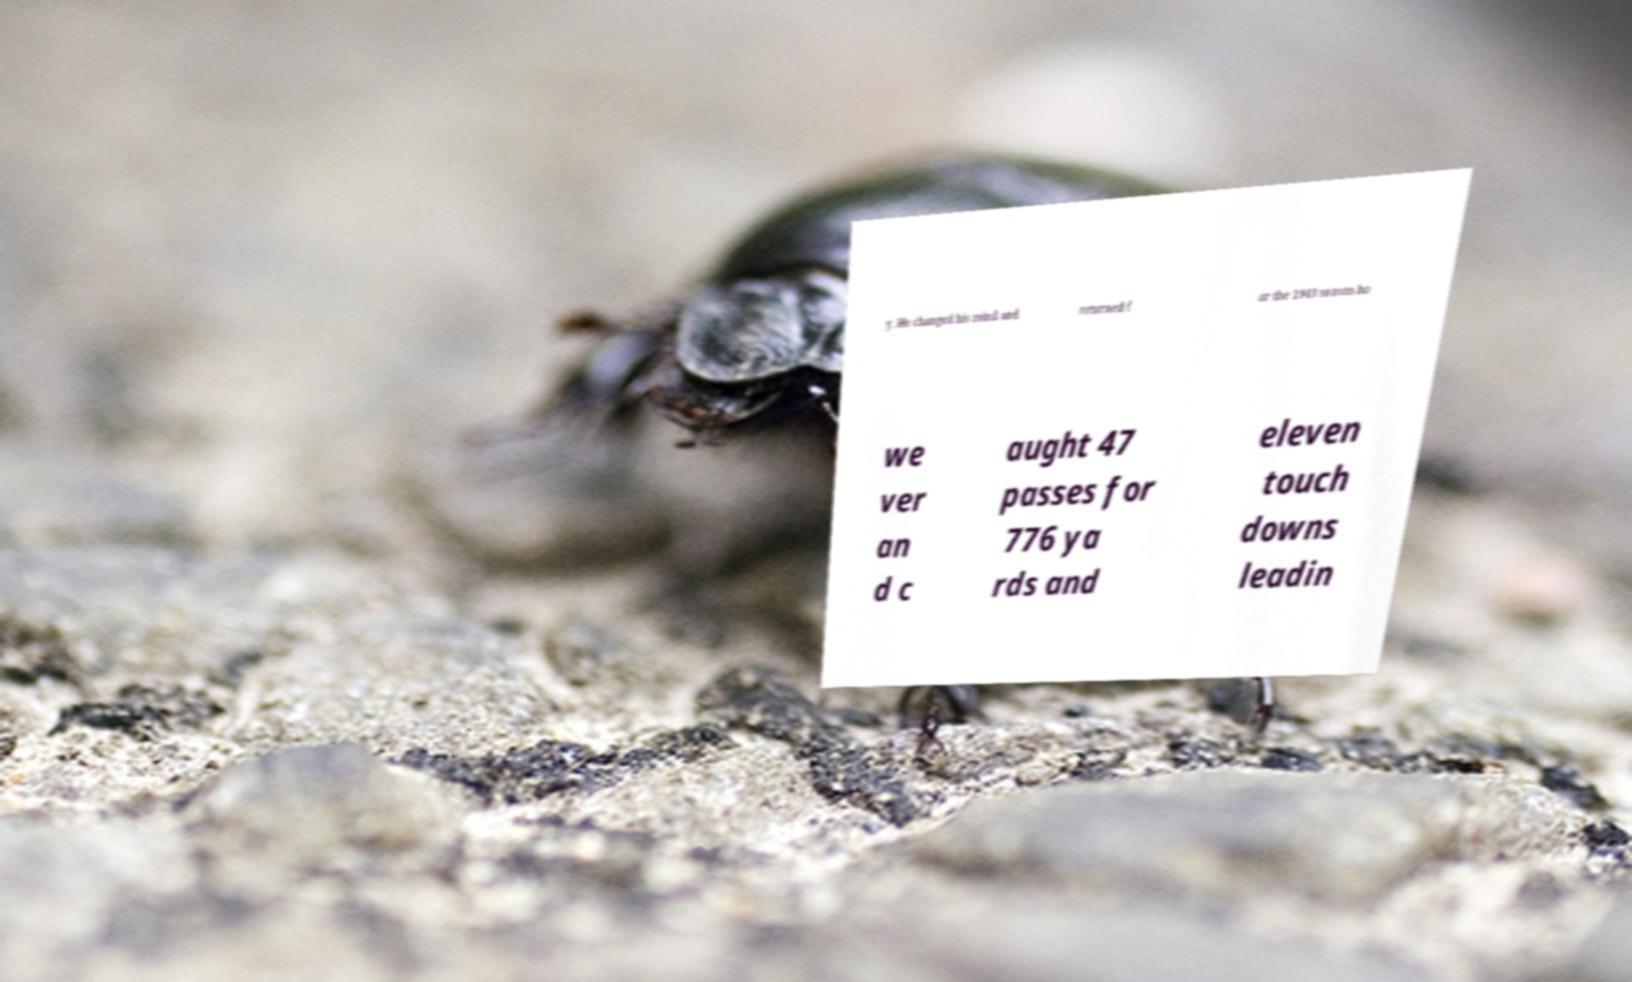Can you read and provide the text displayed in the image?This photo seems to have some interesting text. Can you extract and type it out for me? y. He changed his mind and returned f or the 1943 season ho we ver an d c aught 47 passes for 776 ya rds and eleven touch downs leadin 